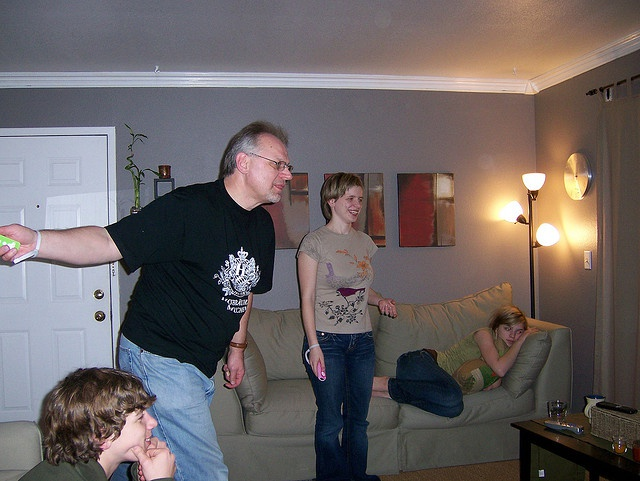Describe the objects in this image and their specific colors. I can see people in gray, black, lightpink, and darkgray tones, couch in gray and black tones, people in gray and black tones, people in gray, black, and lightpink tones, and people in gray, black, and maroon tones in this image. 